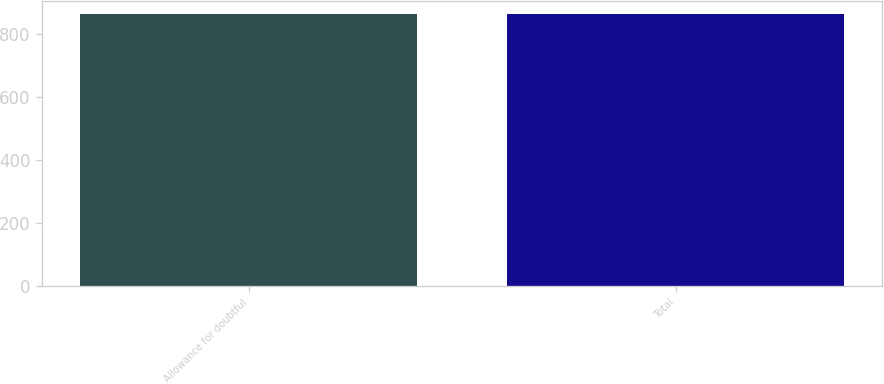Convert chart. <chart><loc_0><loc_0><loc_500><loc_500><bar_chart><fcel>Allowance for doubtful<fcel>Total<nl><fcel>861<fcel>861.1<nl></chart> 